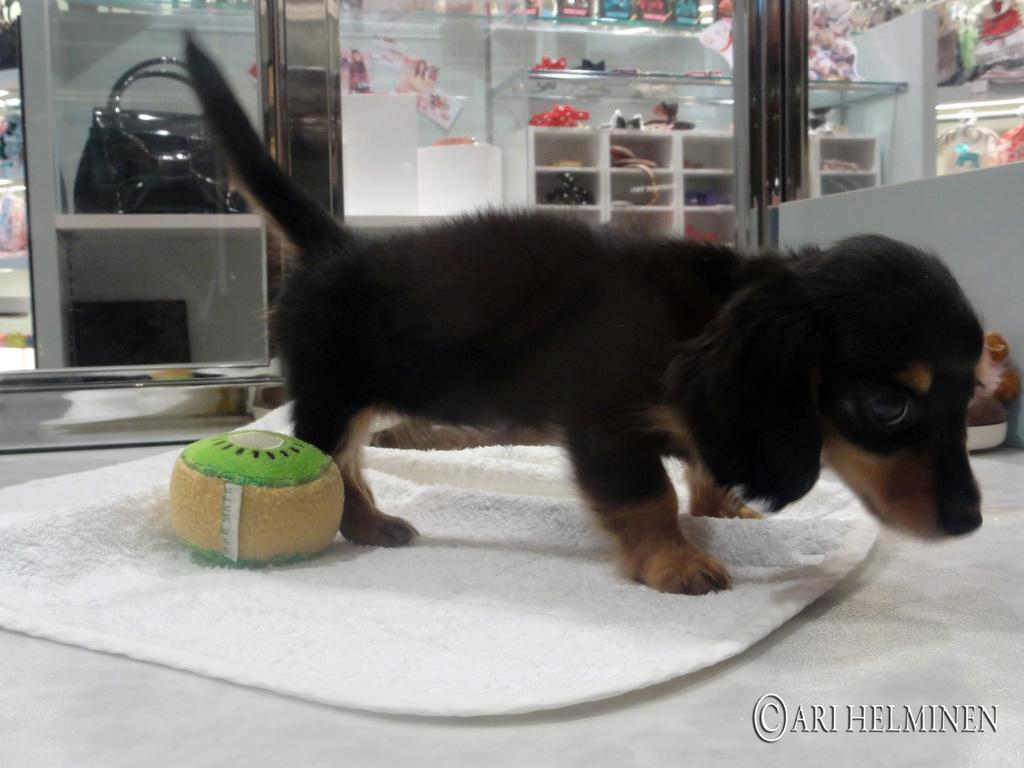What type of animal is in the image? There is a puppy dog in the image. What is the puppy dog standing on? The puppy dog is standing on a white cloth. What can be seen in the background of the image? There are decorative items in a rack in the background of the image. What type of shirt is the puppy dog wearing in the image? There is no shirt present in the image, as the puppy dog is a dog and does not wear clothing. 